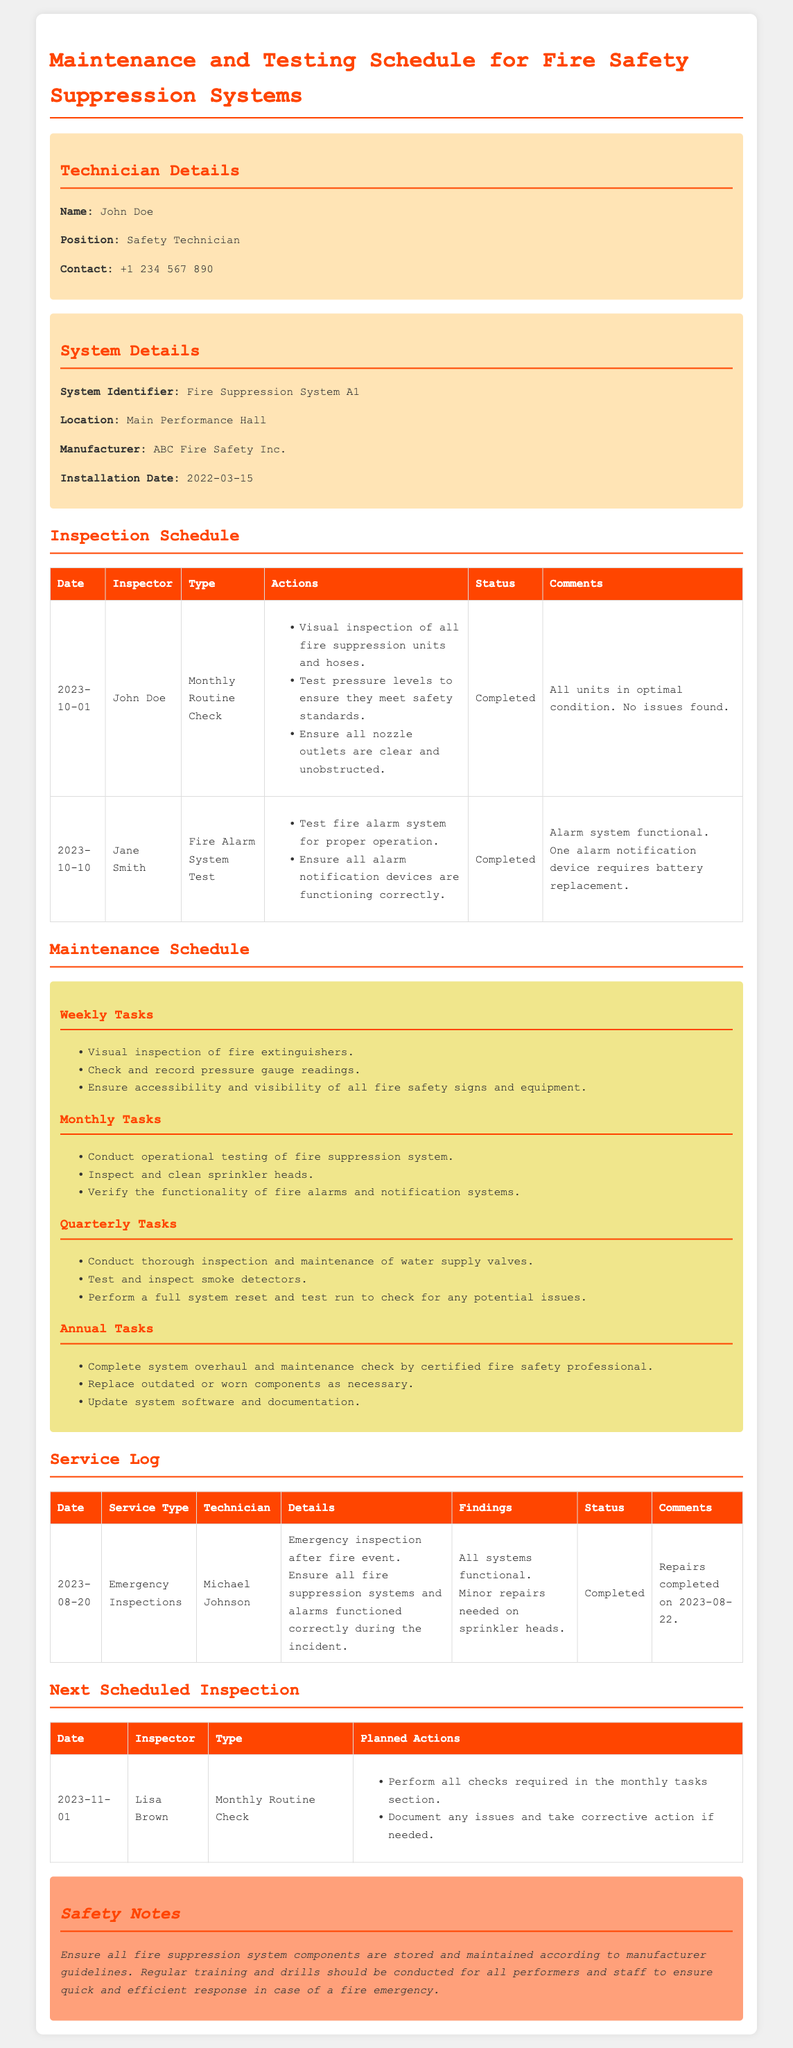What is the name of the technician? The technician's name is mentioned in the technician details section of the document.
Answer: John Doe What is the system identifier? The identifier for the fire safety suppression system is noted under system details.
Answer: Fire Suppression System A1 When was the last routine check performed? The date of the last monthly routine check is listed in the inspection schedule table.
Answer: 2023-10-01 Who conducted the fire alarm system test? The inspector's name for the fire alarm system test is provided in the inspection schedule.
Answer: Jane Smith What type of system maintenance is performed annually? The type of maintenance tasks specified for the annual schedule can be found in the maintenance section.
Answer: Complete system overhaul What was discovered during the emergency inspection? Findings from the emergency inspection can be found in the service log table.
Answer: Minor repairs needed on sprinkler heads When is the next scheduled inspection? The date for the upcoming inspection is clearly stated in the next scheduled inspection section.
Answer: 2023-11-01 What should be documented during the next inspection? The planned actions for the next inspection indicate what should be documented.
Answer: Any issues and take corrective action What is emphasized in the safety notes? The safety notes section outlines key safety protocols regarding the fire suppression systems.
Answer: Regular training and drills 